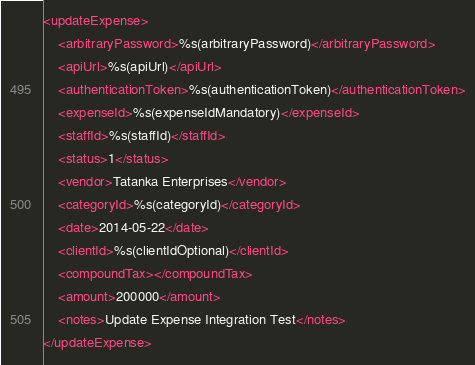<code> <loc_0><loc_0><loc_500><loc_500><_XML_><updateExpense>
	<arbitraryPassword>%s(arbitraryPassword)</arbitraryPassword>
	<apiUrl>%s(apiUrl)</apiUrl>
	<authenticationToken>%s(authenticationToken)</authenticationToken>
	<expenseId>%s(expenseIdMandatory)</expenseId>
	<staffId>%s(staffId)</staffId>
	<status>1</status>
	<vendor>Tatanka Enterprises</vendor>
	<categoryId>%s(categoryId)</categoryId>
	<date>2014-05-22</date>
	<clientId>%s(clientIdOptional)</clientId>
	<compoundTax></compoundTax>
	<amount>200000</amount>
	<notes>Update Expense Integration Test</notes>
</updateExpense></code> 